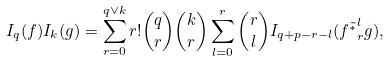Convert formula to latex. <formula><loc_0><loc_0><loc_500><loc_500>I _ { q } ( f ) I _ { k } ( g ) = \sum _ { r = 0 } ^ { q \vee k } r ! { \binom { q } { r } } { \binom { k } { r } } \sum _ { l = 0 } ^ { r } { \binom { r } { l } } I _ { q + p - r - l } ( f \tilde { ^ { * } } _ { r } ^ { l } g ) ,</formula> 